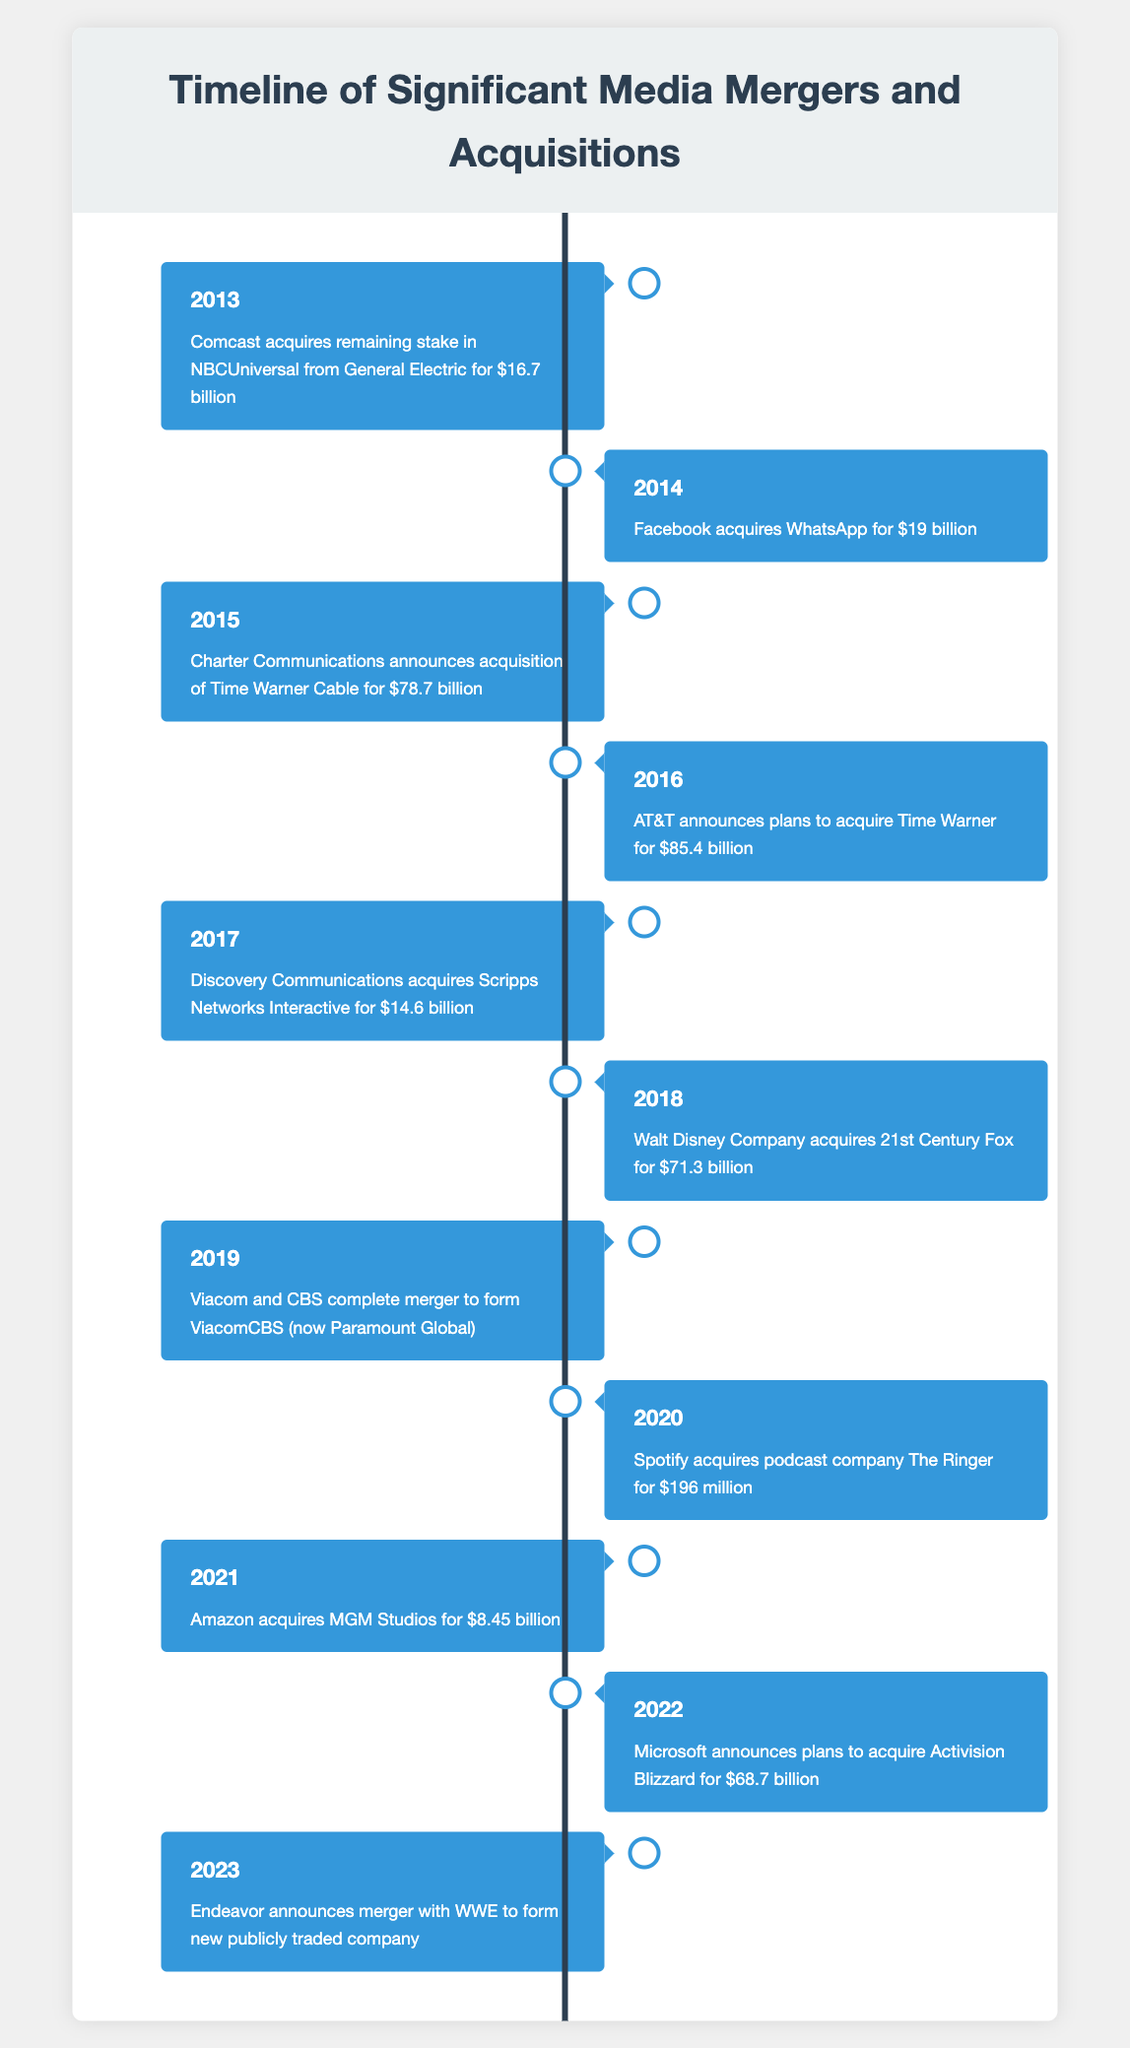What event occurred in 2016? In 2016, AT&T announced plans to acquire Time Warner for $85.4 billion, which is explicitly mentioned in the timeline for that year.
Answer: AT&T announces plans to acquire Time Warner for $85.4 billion Which acquisition took place for less than $20 billion? The acquisition of WhatsApp by Facebook in 2014 for $19 billion is the only event listed that occurred for less than $20 billion.
Answer: Facebook acquires WhatsApp for $19 billion How much did Disney pay to acquire 21st Century Fox? According to the table, the Walt Disney Company acquired 21st Century Fox for $71.3 billion in 2018.
Answer: $71.3 billion What year saw the largest acquisition amount? The largest acquisition amount is from AT&T's plans to acquire Time Warner for $85.4 billion in 2016. Therefore, 2016 saw the largest acquisition amount.
Answer: 2016 Was there a merger involving Viacom in the past decade? Yes, there was a merger which involved Viacom and CBS completing a merger to form ViacomCBS (now Paramount Global) in 2019, which confirms the occurrence of this event.
Answer: Yes What is the total amount spent on acquisitions in the years 2013, 2014, and 2021 combined? The total amount for 2013 (16.7 billion), 2014 (19 billion), and 2021 (8.45 billion) is calculated as 16.7 + 19 + 8.45 = 44.15 billion. Therefore, the combined amount is $44.15 billion.
Answer: $44.15 billion How many acquisitions involved technology companies? The acquisitions involving technology companies include Facebook acquiring WhatsApp in 2014 and Microsoft planning to acquire Activision Blizzard in 2022. This totals two technology company acquisitions.
Answer: 2 Which event is the most recent in the table? The most recent event in the table is Endeavor's announcement of a merger with WWE to form a new publicly traded company in 2023, as it is the last entry in the timeline.
Answer: Endeavor announces merger with WWE in 2023 In which year did Spotify acquire a podcast company? In 2020, Spotify acquired the podcast company The Ringer for $196 million, which can be found directly in the table.
Answer: 2020 